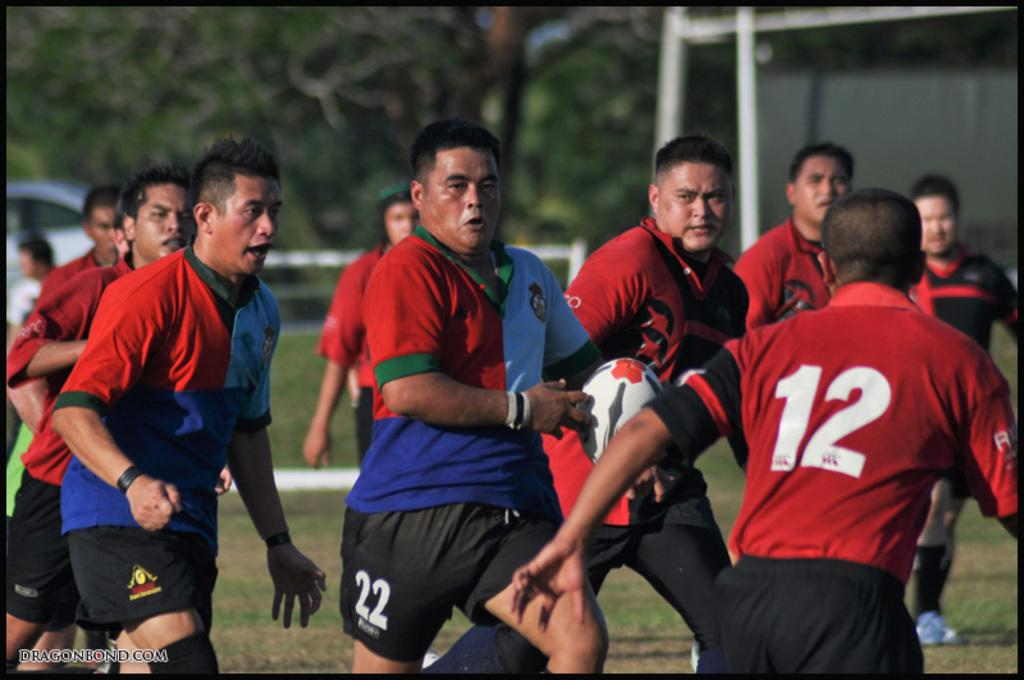What are the people in the foreground of the picture doing? The people are running and playing rugby. What can be seen in the background of the picture? There are trees, poles, a car, and greenery in the background of the picture. How many different types of objects can be seen in the background? There are four different types of objects in the background: trees, poles, a car, and greenery. Is there a lake visible in the image? No, there is no lake present in the image. Can you see a shop in the background of the image? No, there is no shop visible in the image. 